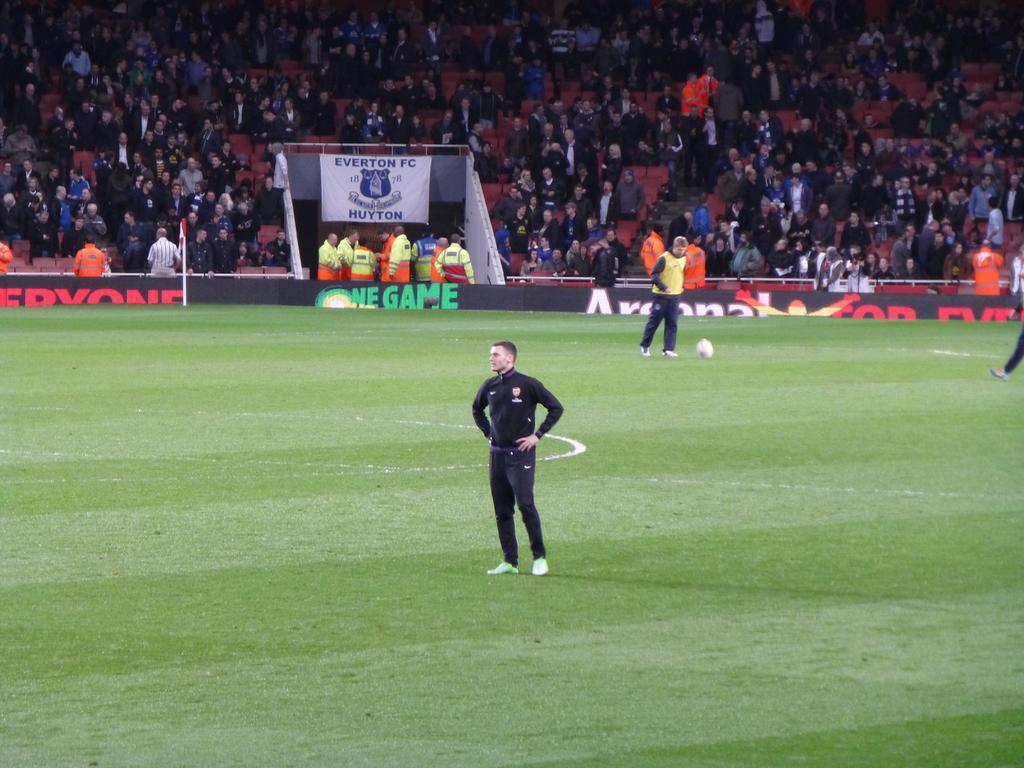Could you give a brief overview of what you see in this image? In this image I can see few people are on the ground. These people are wearing the different color dresses. I can see the white color ball on the ground. In the background I can see the boards and banner. To the side of the banner I can see many people in the stadium. These people are wearing the different color dresses. 